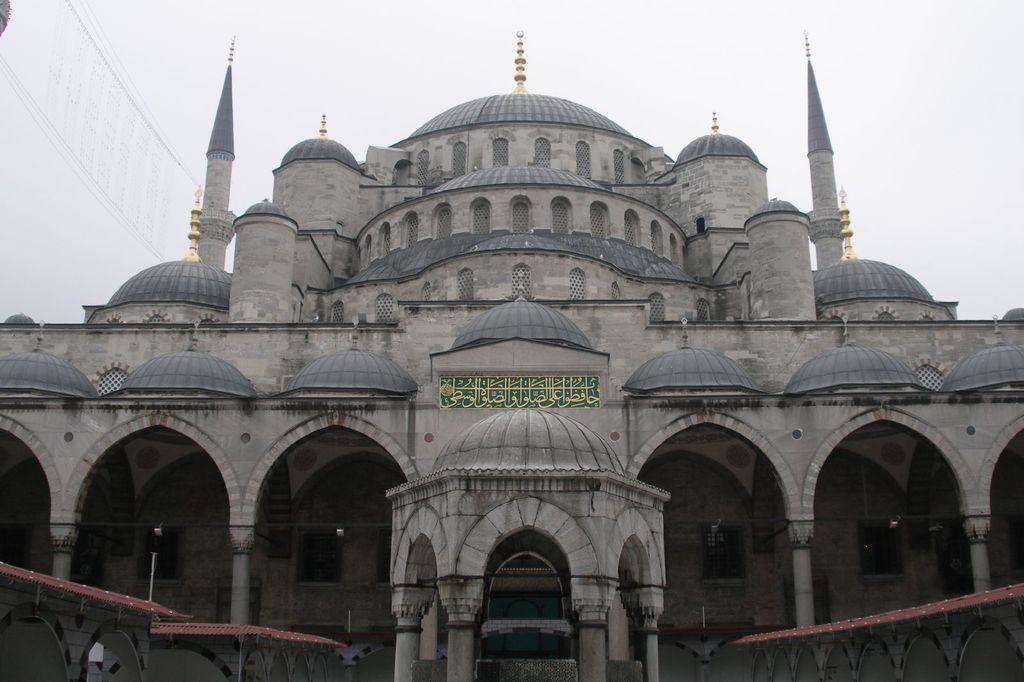Can you describe this image briefly? In the picture we can see a historical mosque, which is gray in color and a moon symbol on the top of it and in the background we can see a sky. 